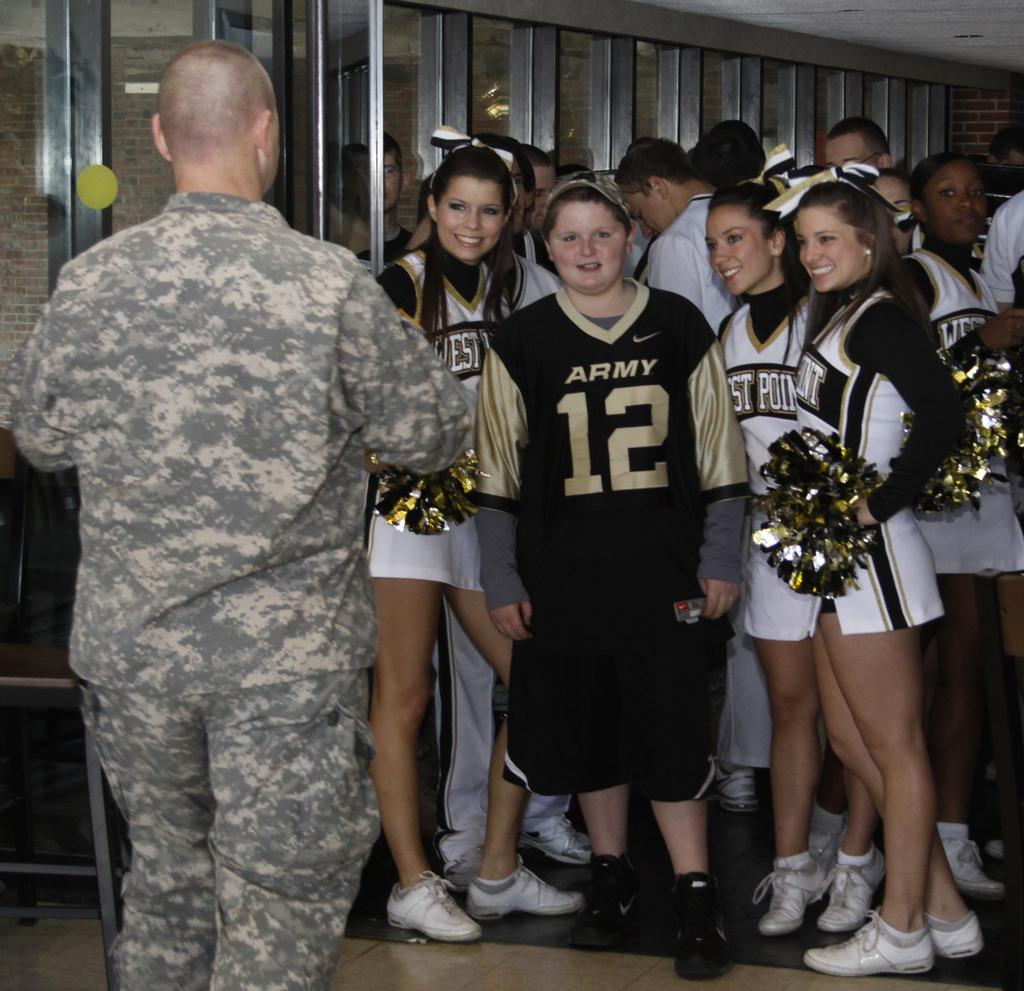Provide a one-sentence caption for the provided image. a military person is speaking to a group of cheerleaders and a girl in an Army jersey at west point. 